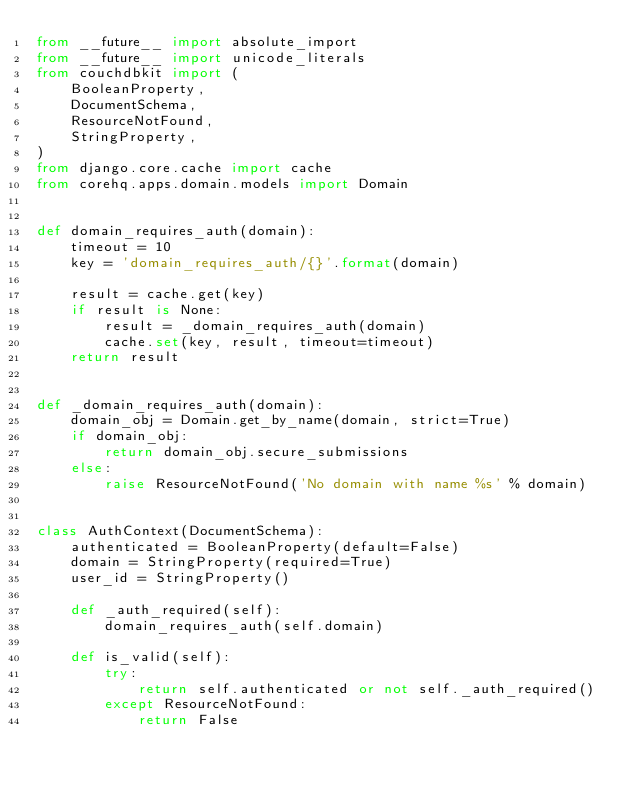<code> <loc_0><loc_0><loc_500><loc_500><_Python_>from __future__ import absolute_import
from __future__ import unicode_literals
from couchdbkit import (
    BooleanProperty,
    DocumentSchema,
    ResourceNotFound,
    StringProperty,
)
from django.core.cache import cache
from corehq.apps.domain.models import Domain


def domain_requires_auth(domain):
    timeout = 10
    key = 'domain_requires_auth/{}'.format(domain)

    result = cache.get(key)
    if result is None:
        result = _domain_requires_auth(domain)
        cache.set(key, result, timeout=timeout)
    return result


def _domain_requires_auth(domain):
    domain_obj = Domain.get_by_name(domain, strict=True)
    if domain_obj:
        return domain_obj.secure_submissions
    else:
        raise ResourceNotFound('No domain with name %s' % domain)


class AuthContext(DocumentSchema):
    authenticated = BooleanProperty(default=False)
    domain = StringProperty(required=True)
    user_id = StringProperty()

    def _auth_required(self):
        domain_requires_auth(self.domain)

    def is_valid(self):
        try:
            return self.authenticated or not self._auth_required()
        except ResourceNotFound:
            return False

</code> 